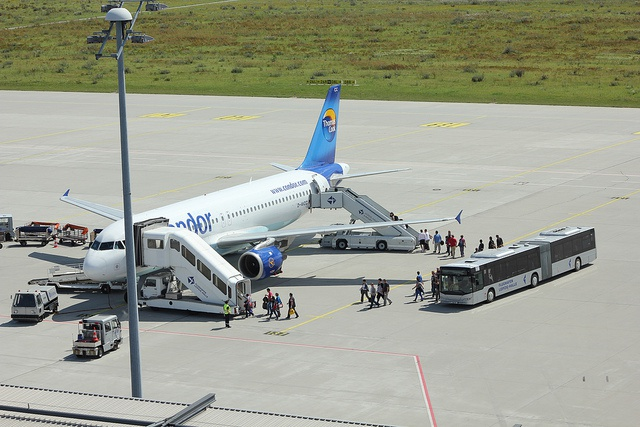Describe the objects in this image and their specific colors. I can see airplane in olive, white, darkgray, lightblue, and lightgray tones, bus in olive, black, darkgray, gray, and lightgray tones, truck in olive, darkgray, black, gray, and lightgray tones, truck in olive, black, darkgray, gray, and lightgray tones, and people in olive, black, gray, darkgray, and lightgray tones in this image. 